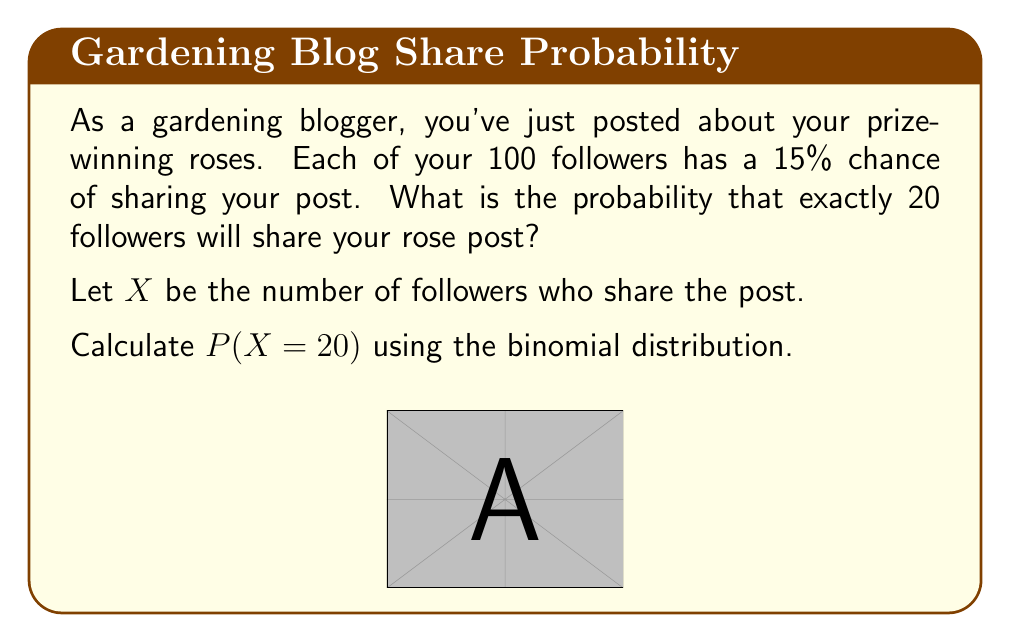Give your solution to this math problem. To solve this problem, we'll use the binomial probability mass function:

$$P(X = k) = \binom{n}{k} p^k (1-p)^{n-k}$$

Where:
$n$ = number of trials (followers) = 100
$k$ = number of successes (shares) = 20
$p$ = probability of success (share) = 0.15

Step 1: Calculate the binomial coefficient
$$\binom{100}{20} = \frac{100!}{20!(100-20)!} = 5.36 \times 10^{20}$$

Step 2: Calculate $p^k$
$$0.15^{20} = 3.19 \times 10^{-17}$$

Step 3: Calculate $(1-p)^{n-k}$
$$(1-0.15)^{100-20} = 0.85^{80} = 1.56 \times 10^{-7}$$

Step 4: Multiply all terms
$$P(X = 20) = 5.36 \times 10^{20} \times 3.19 \times 10^{-17} \times 1.56 \times 10^{-7}$$

Step 5: Simplify
$$P(X = 20) = 0.0266$$
Answer: 0.0266 or 2.66% 